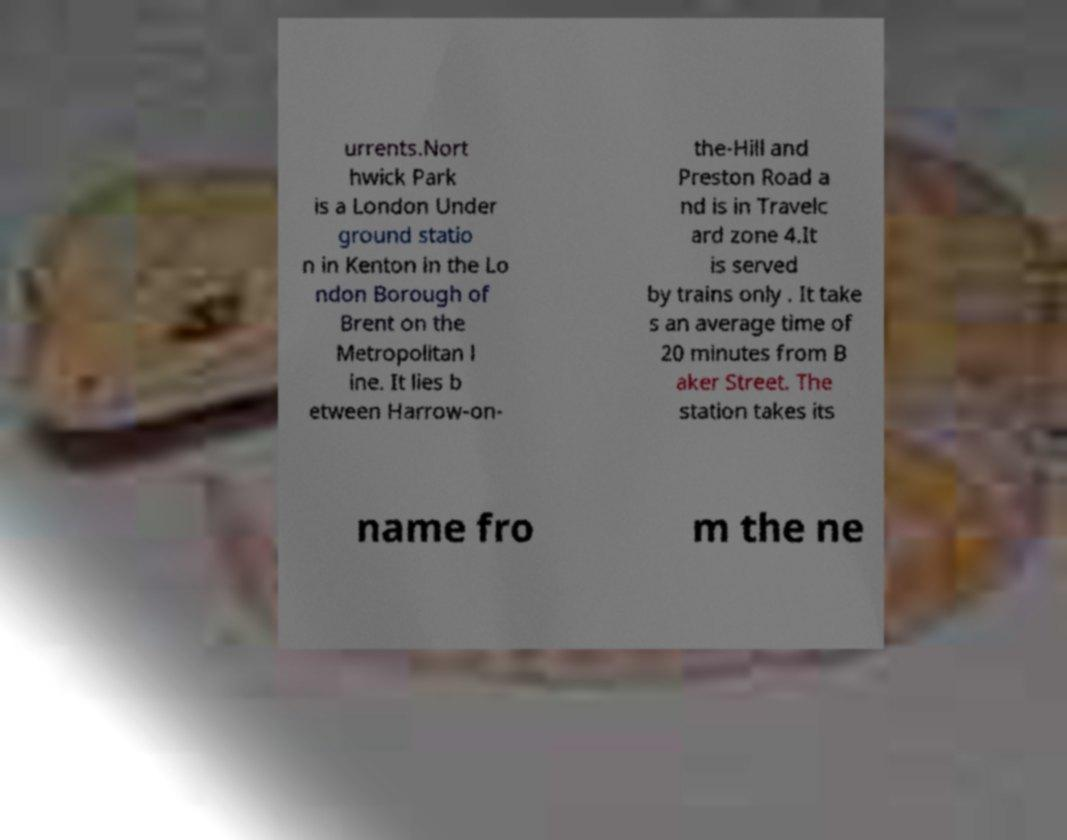Please identify and transcribe the text found in this image. urrents.Nort hwick Park is a London Under ground statio n in Kenton in the Lo ndon Borough of Brent on the Metropolitan l ine. It lies b etween Harrow-on- the-Hill and Preston Road a nd is in Travelc ard zone 4.It is served by trains only . It take s an average time of 20 minutes from B aker Street. The station takes its name fro m the ne 